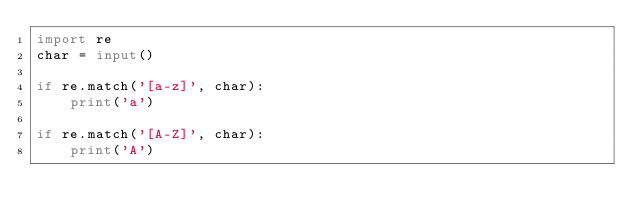Convert code to text. <code><loc_0><loc_0><loc_500><loc_500><_Python_>import re
char = input()

if re.match('[a-z]', char):
    print('a')

if re.match('[A-Z]', char):
    print('A')</code> 